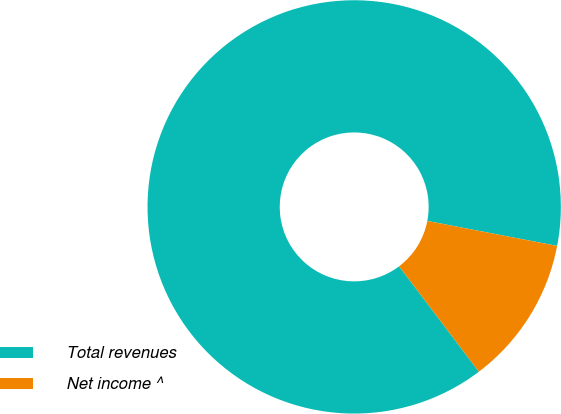Convert chart. <chart><loc_0><loc_0><loc_500><loc_500><pie_chart><fcel>Total revenues<fcel>Net income ^<nl><fcel>88.33%<fcel>11.67%<nl></chart> 